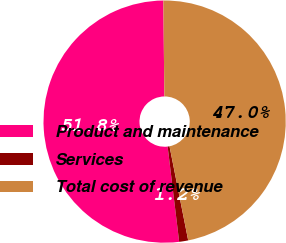Convert chart to OTSL. <chart><loc_0><loc_0><loc_500><loc_500><pie_chart><fcel>Product and maintenance<fcel>Services<fcel>Total cost of revenue<nl><fcel>51.75%<fcel>1.2%<fcel>47.05%<nl></chart> 